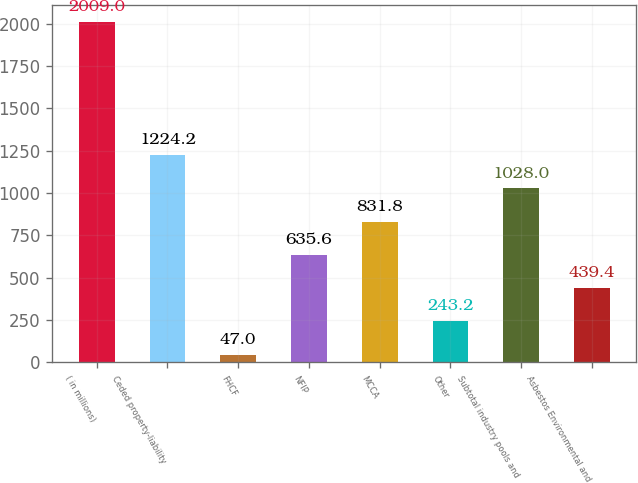<chart> <loc_0><loc_0><loc_500><loc_500><bar_chart><fcel>( in millions)<fcel>Ceded property-liability<fcel>FHCF<fcel>NFIP<fcel>MCCA<fcel>Other<fcel>Subtotal industry pools and<fcel>Asbestos Environmental and<nl><fcel>2009<fcel>1224.2<fcel>47<fcel>635.6<fcel>831.8<fcel>243.2<fcel>1028<fcel>439.4<nl></chart> 